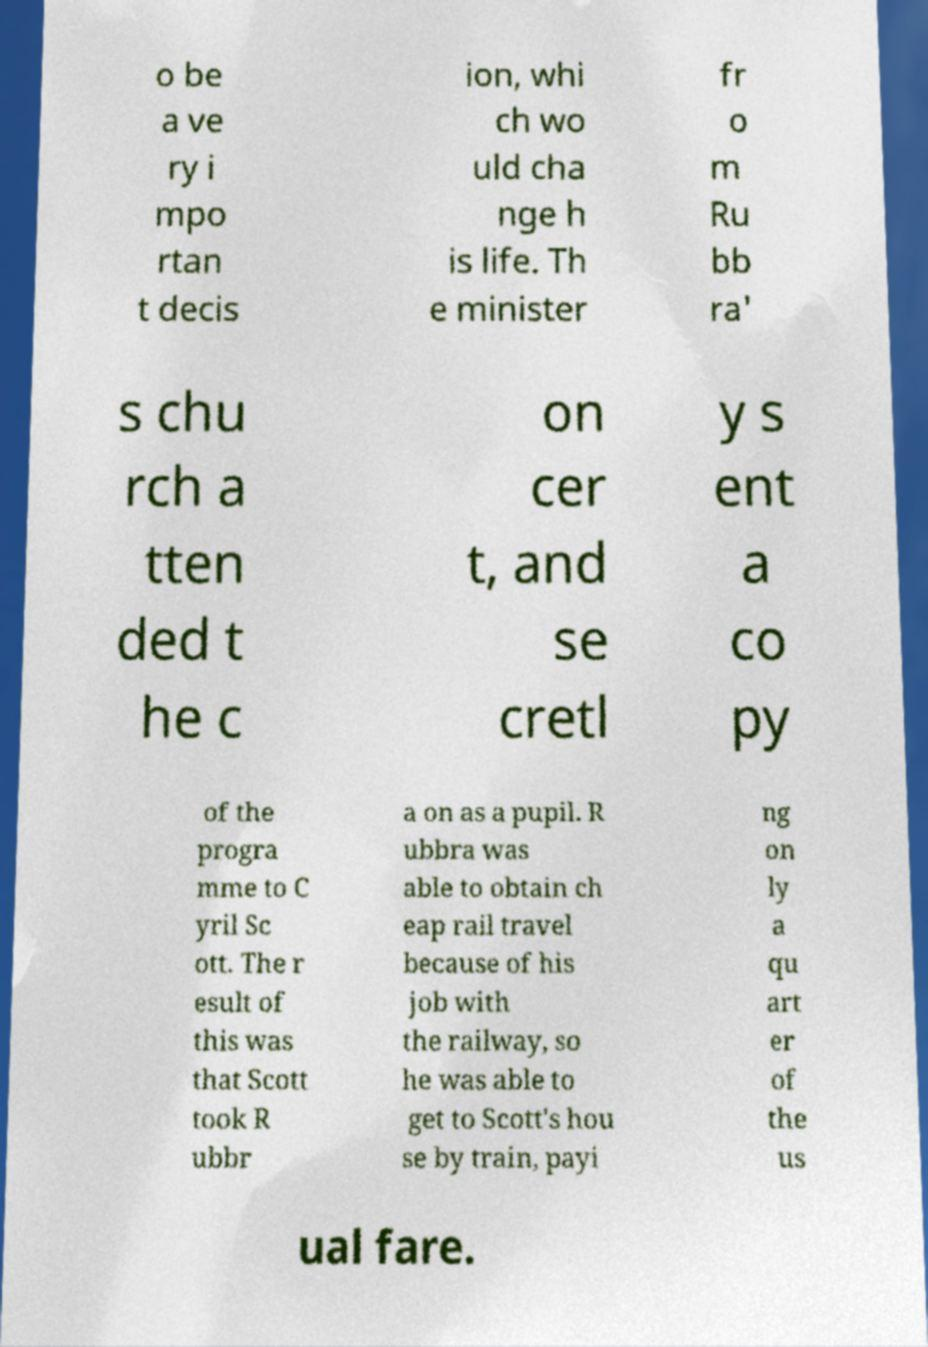I need the written content from this picture converted into text. Can you do that? o be a ve ry i mpo rtan t decis ion, whi ch wo uld cha nge h is life. Th e minister fr o m Ru bb ra' s chu rch a tten ded t he c on cer t, and se cretl y s ent a co py of the progra mme to C yril Sc ott. The r esult of this was that Scott took R ubbr a on as a pupil. R ubbra was able to obtain ch eap rail travel because of his job with the railway, so he was able to get to Scott's hou se by train, payi ng on ly a qu art er of the us ual fare. 